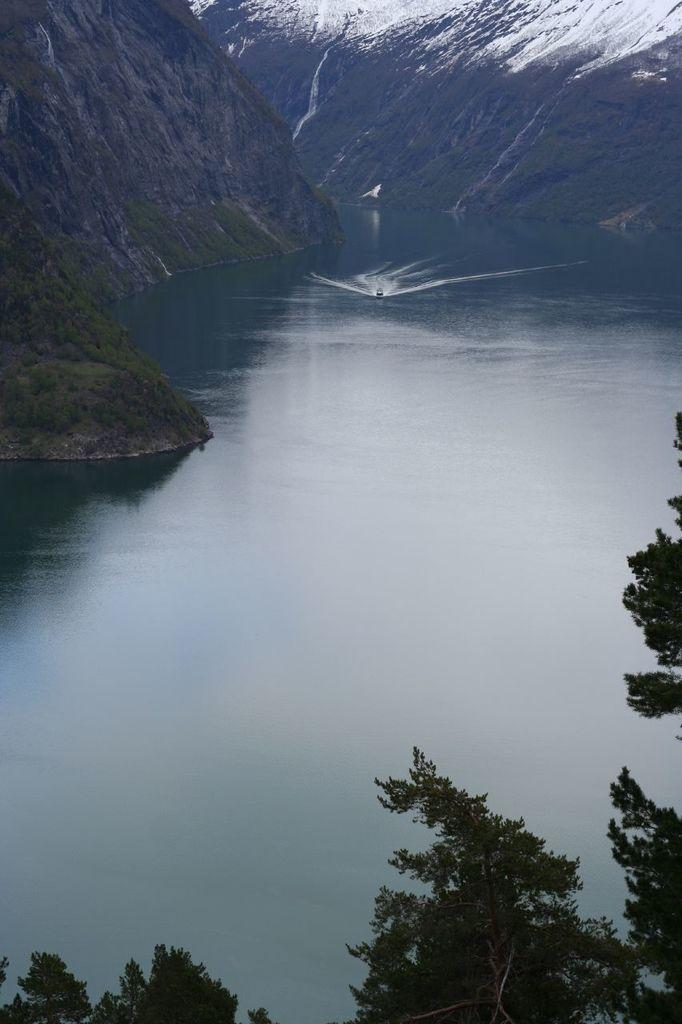What type of vegetation is visible at the bottom of the image? There are branches of trees at the bottom of the image. What natural feature is in the middle of the image? There is a sea in the middle of the image. What type of landform can be seen in the background of the image? There is a mountain in the background of the image. What time of day is depicted in the image based on the position of the hour hand on a clock? There is no clock or hour hand present in the image, so it is not possible to determine the time of day. What type of plastic object can be seen floating in the sea in the image? There is no plastic object visible in the sea in the image. 